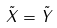Convert formula to latex. <formula><loc_0><loc_0><loc_500><loc_500>\tilde { X } = \tilde { Y }</formula> 